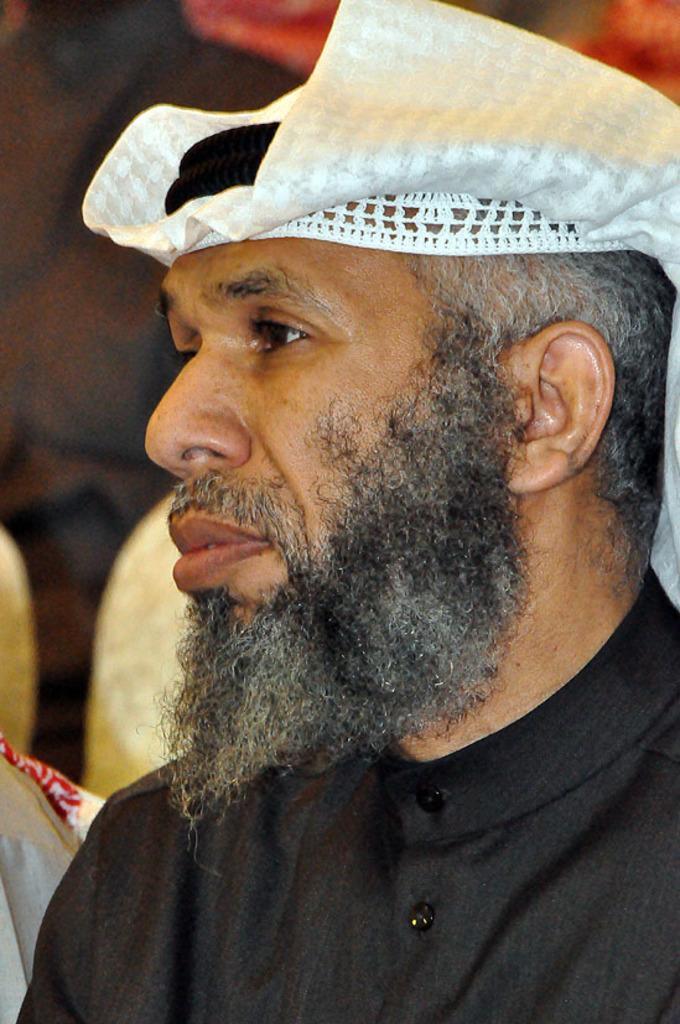Can you describe this image briefly? In this image there is a man sitting on a chair, in the background it is blurred. 